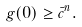Convert formula to latex. <formula><loc_0><loc_0><loc_500><loc_500>g ( 0 ) \geq \bar { c } ^ { n } .</formula> 